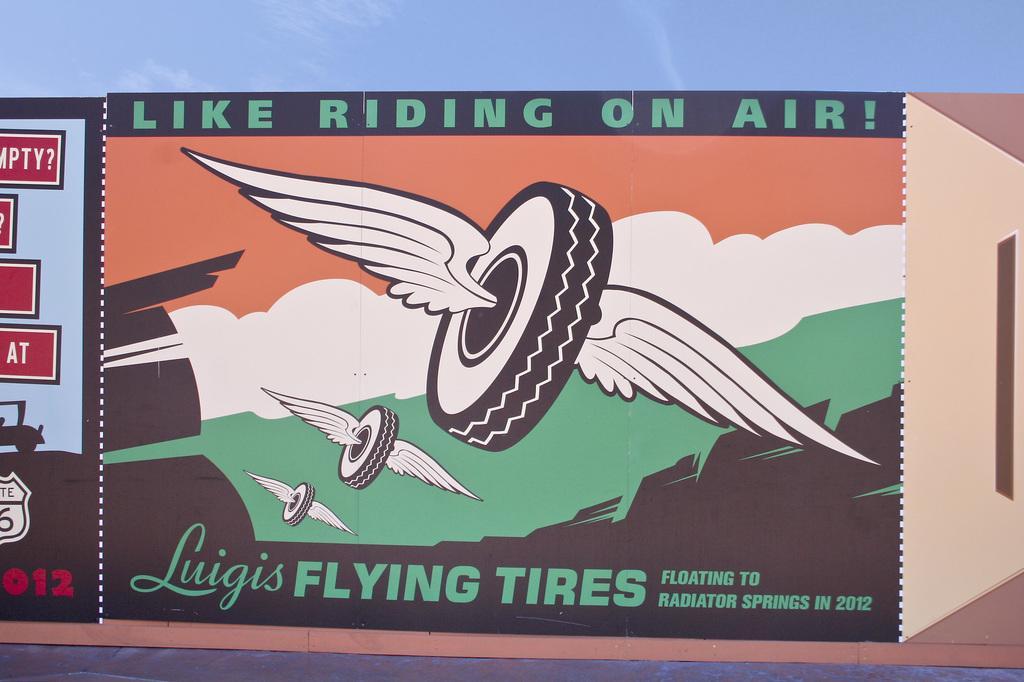Describe this image in one or two sentences. This image is a painting. In this image we can see tyre, wings and text. 